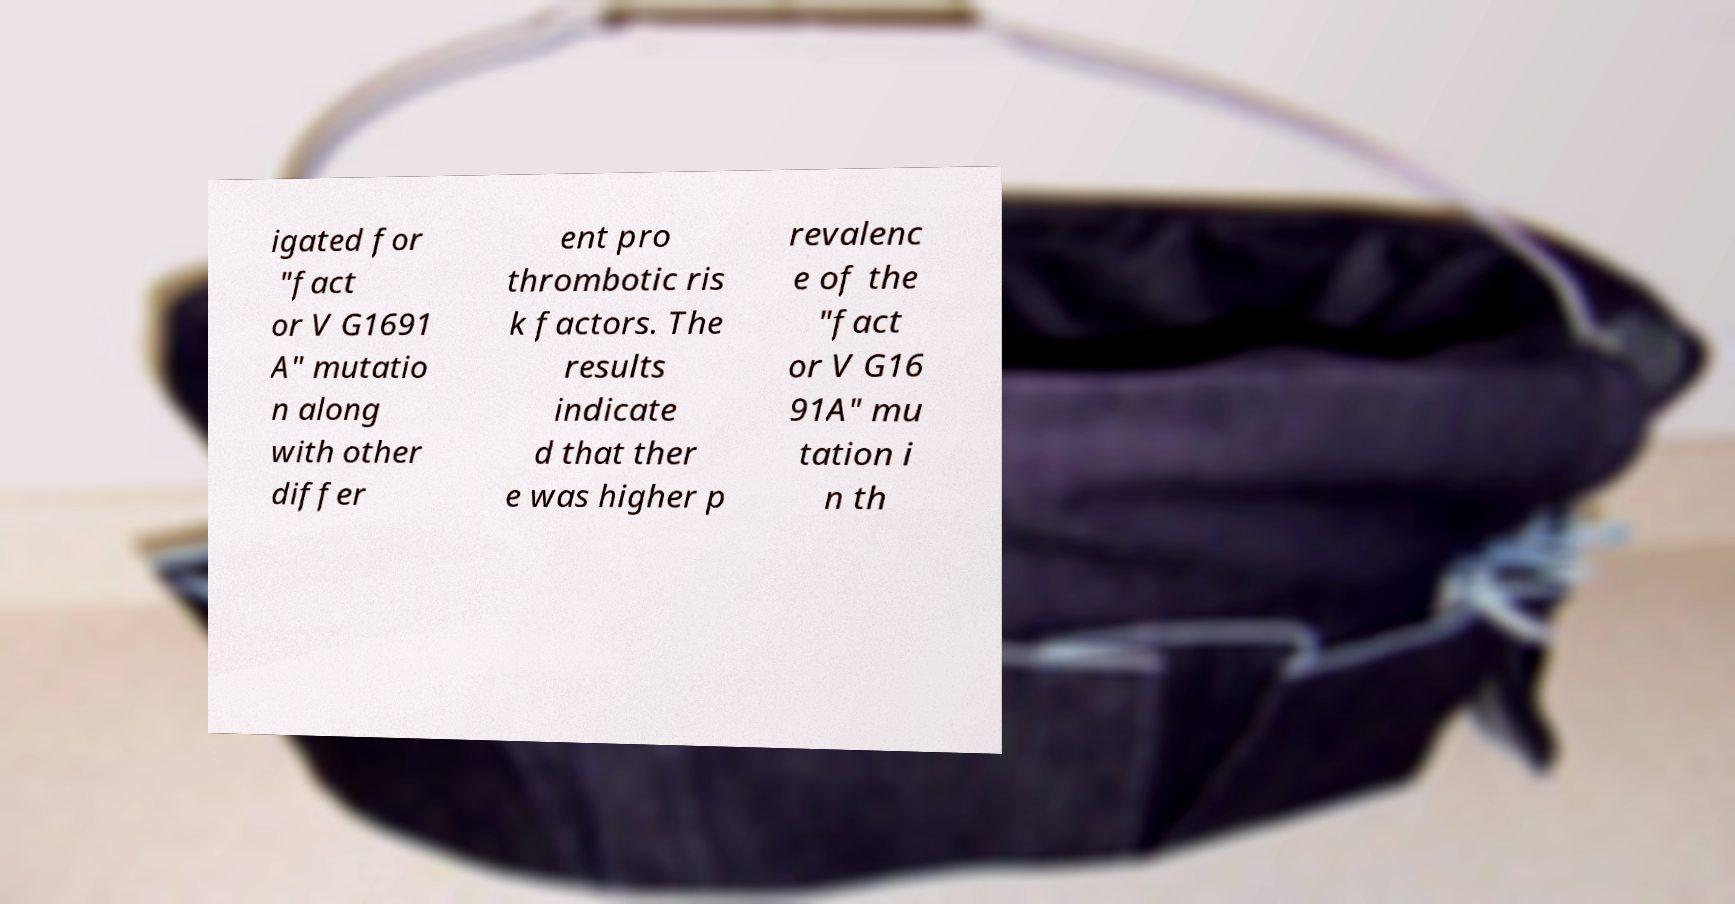Can you accurately transcribe the text from the provided image for me? igated for "fact or V G1691 A" mutatio n along with other differ ent pro thrombotic ris k factors. The results indicate d that ther e was higher p revalenc e of the "fact or V G16 91A" mu tation i n th 